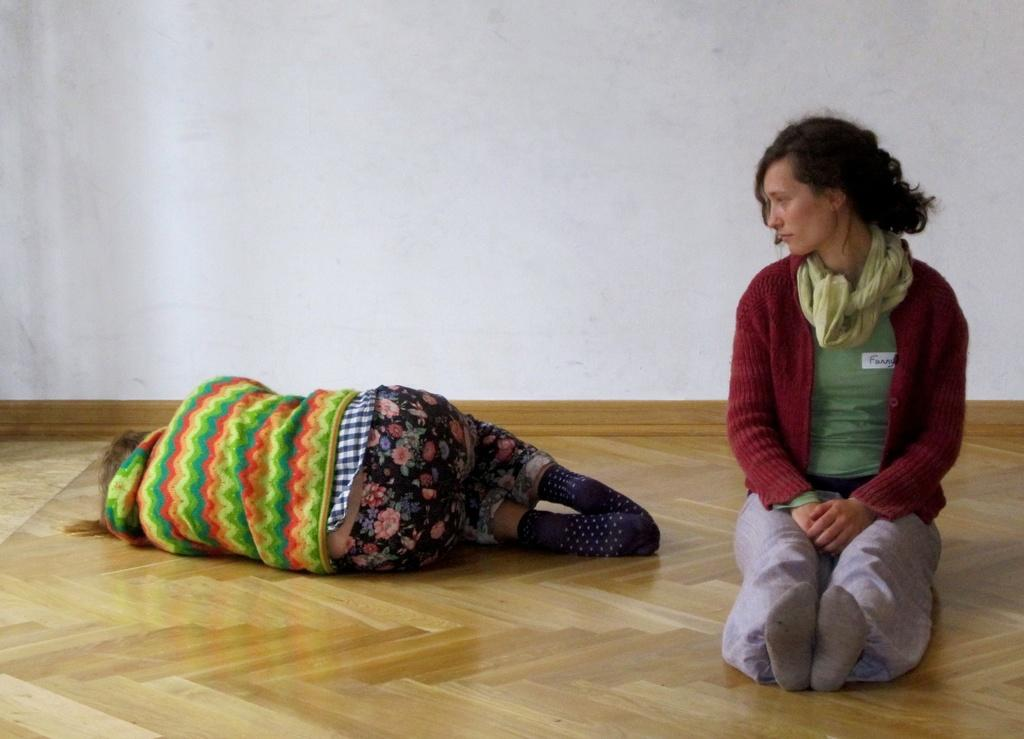How many people are in the image? There are two people in the image. What is one person doing in the image? One person is lying on the wooden floor. How is the other person dressed in the image? The other person is wearing a jacket and a scarf. What type of flooring is present in the image? There is a wooden floor in the image. What is visible in the background of the image? There is a wall in the image. What type of minister is present in the image? There is no minister present in the image. How does the wooden floor turn into a carpet in the image? The wooden floor does not turn into a carpet in the image; it remains wooden throughout. 